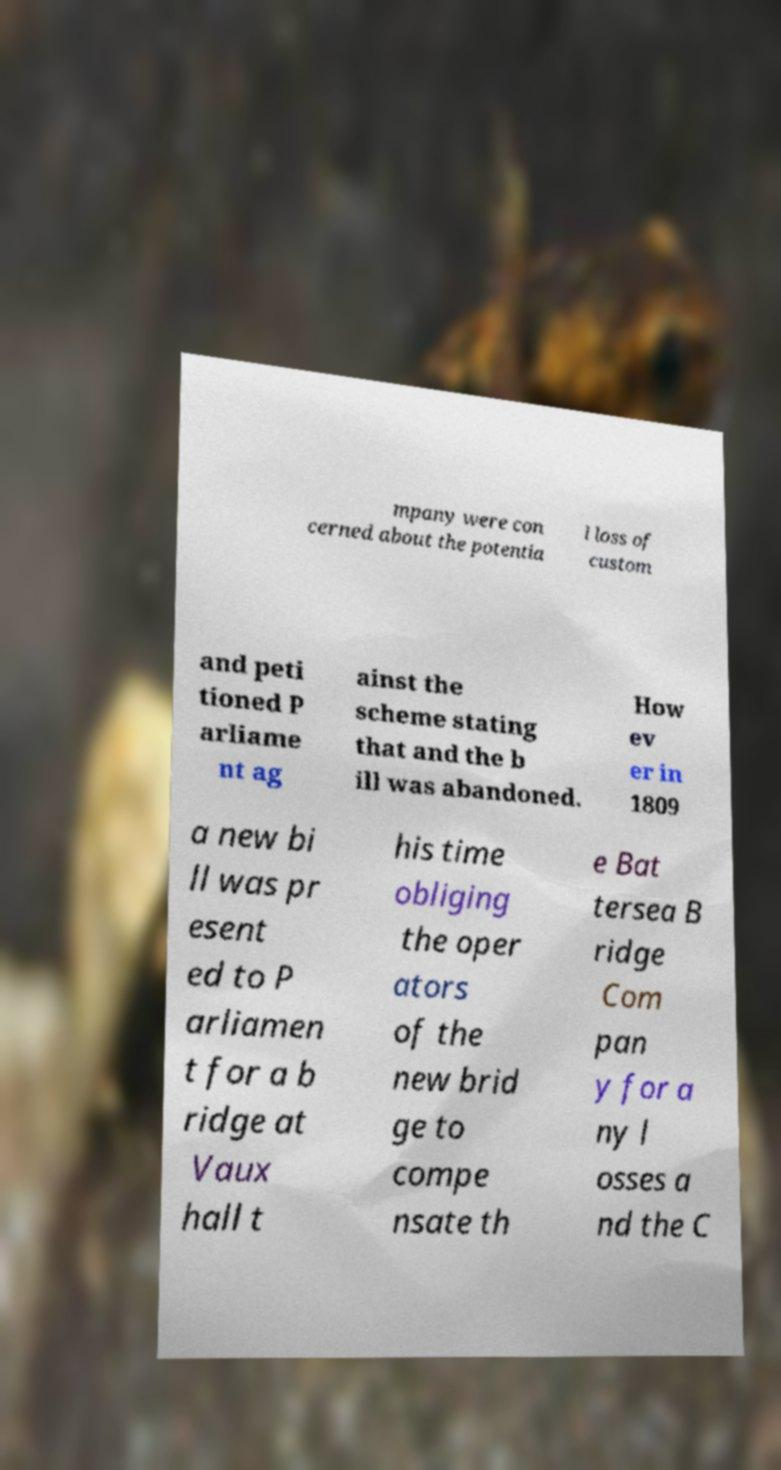I need the written content from this picture converted into text. Can you do that? mpany were con cerned about the potentia l loss of custom and peti tioned P arliame nt ag ainst the scheme stating that and the b ill was abandoned. How ev er in 1809 a new bi ll was pr esent ed to P arliamen t for a b ridge at Vaux hall t his time obliging the oper ators of the new brid ge to compe nsate th e Bat tersea B ridge Com pan y for a ny l osses a nd the C 